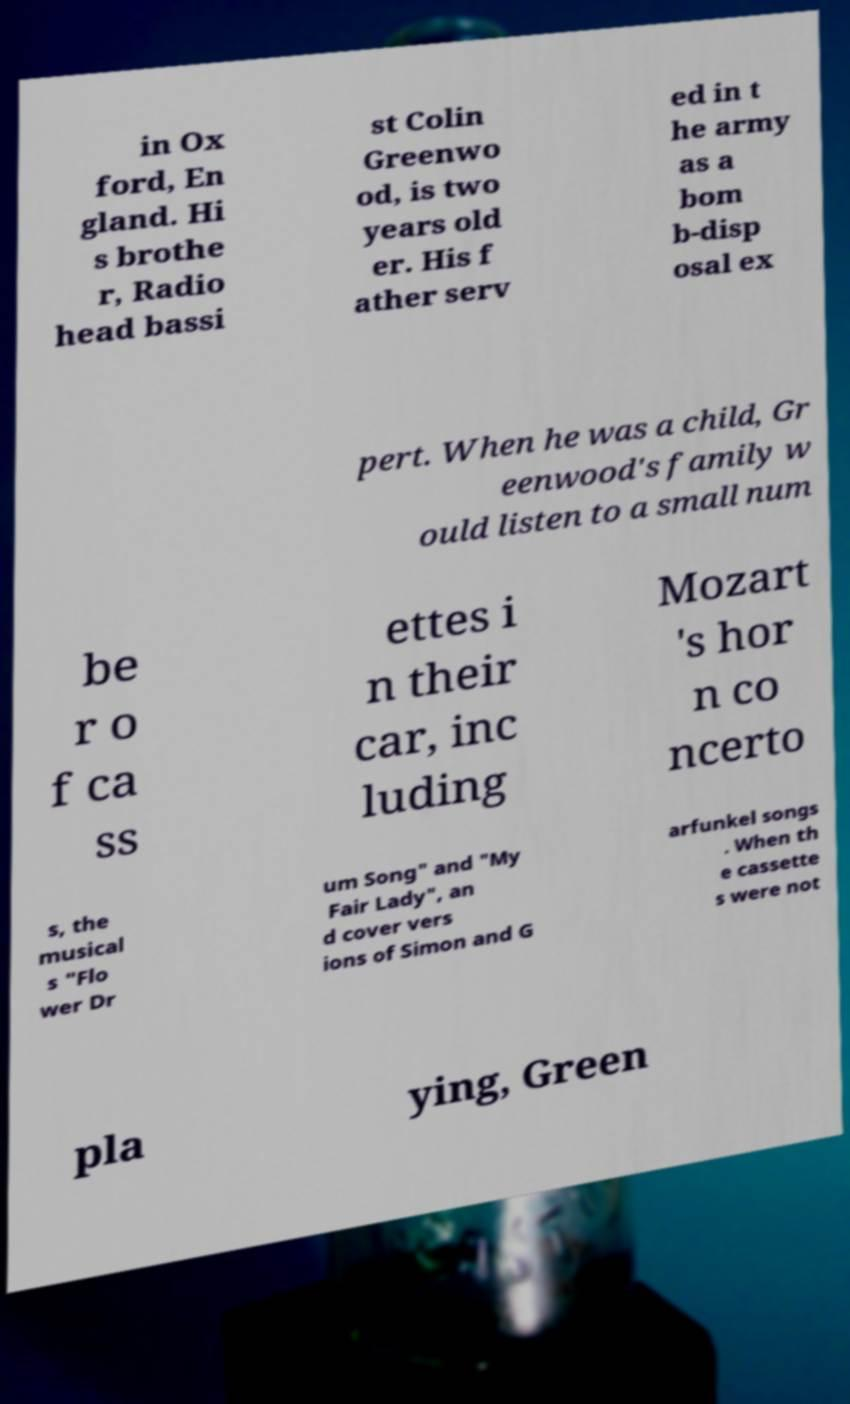There's text embedded in this image that I need extracted. Can you transcribe it verbatim? in Ox ford, En gland. Hi s brothe r, Radio head bassi st Colin Greenwo od, is two years old er. His f ather serv ed in t he army as a bom b-disp osal ex pert. When he was a child, Gr eenwood's family w ould listen to a small num be r o f ca ss ettes i n their car, inc luding Mozart 's hor n co ncerto s, the musical s "Flo wer Dr um Song" and "My Fair Lady", an d cover vers ions of Simon and G arfunkel songs . When th e cassette s were not pla ying, Green 